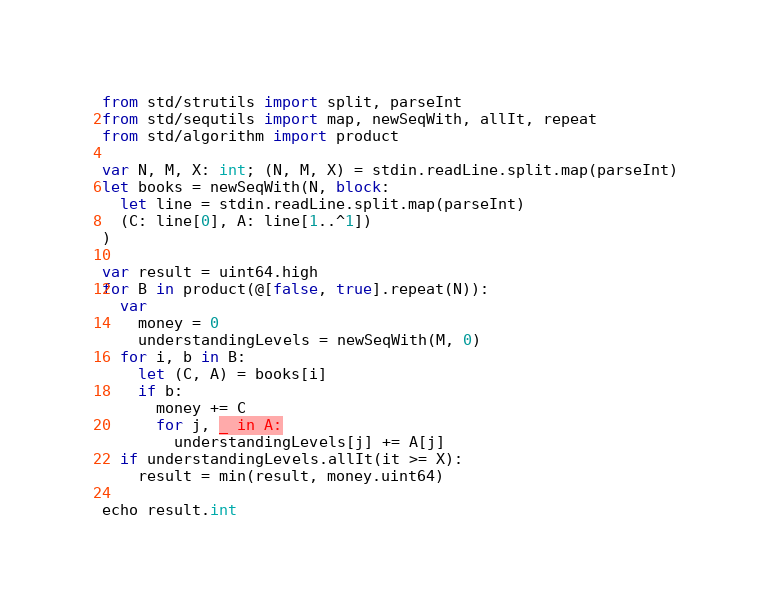Convert code to text. <code><loc_0><loc_0><loc_500><loc_500><_Nim_>from std/strutils import split, parseInt
from std/sequtils import map, newSeqWith, allIt, repeat
from std/algorithm import product

var N, M, X: int; (N, M, X) = stdin.readLine.split.map(parseInt)
let books = newSeqWith(N, block:
  let line = stdin.readLine.split.map(parseInt)
  (C: line[0], A: line[1..^1])
)

var result = uint64.high
for B in product(@[false, true].repeat(N)):
  var
    money = 0
    understandingLevels = newSeqWith(M, 0)
  for i, b in B:
    let (C, A) = books[i]
    if b:
      money += C
      for j, _ in A:
        understandingLevels[j] += A[j]
  if understandingLevels.allIt(it >= X):
    result = min(result, money.uint64)

echo result.int
</code> 